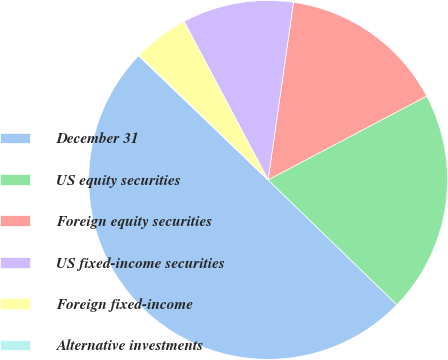Convert chart. <chart><loc_0><loc_0><loc_500><loc_500><pie_chart><fcel>December 31<fcel>US equity securities<fcel>Foreign equity securities<fcel>US fixed-income securities<fcel>Foreign fixed-income<fcel>Alternative investments<nl><fcel>49.9%<fcel>19.99%<fcel>15.0%<fcel>10.02%<fcel>5.03%<fcel>0.05%<nl></chart> 